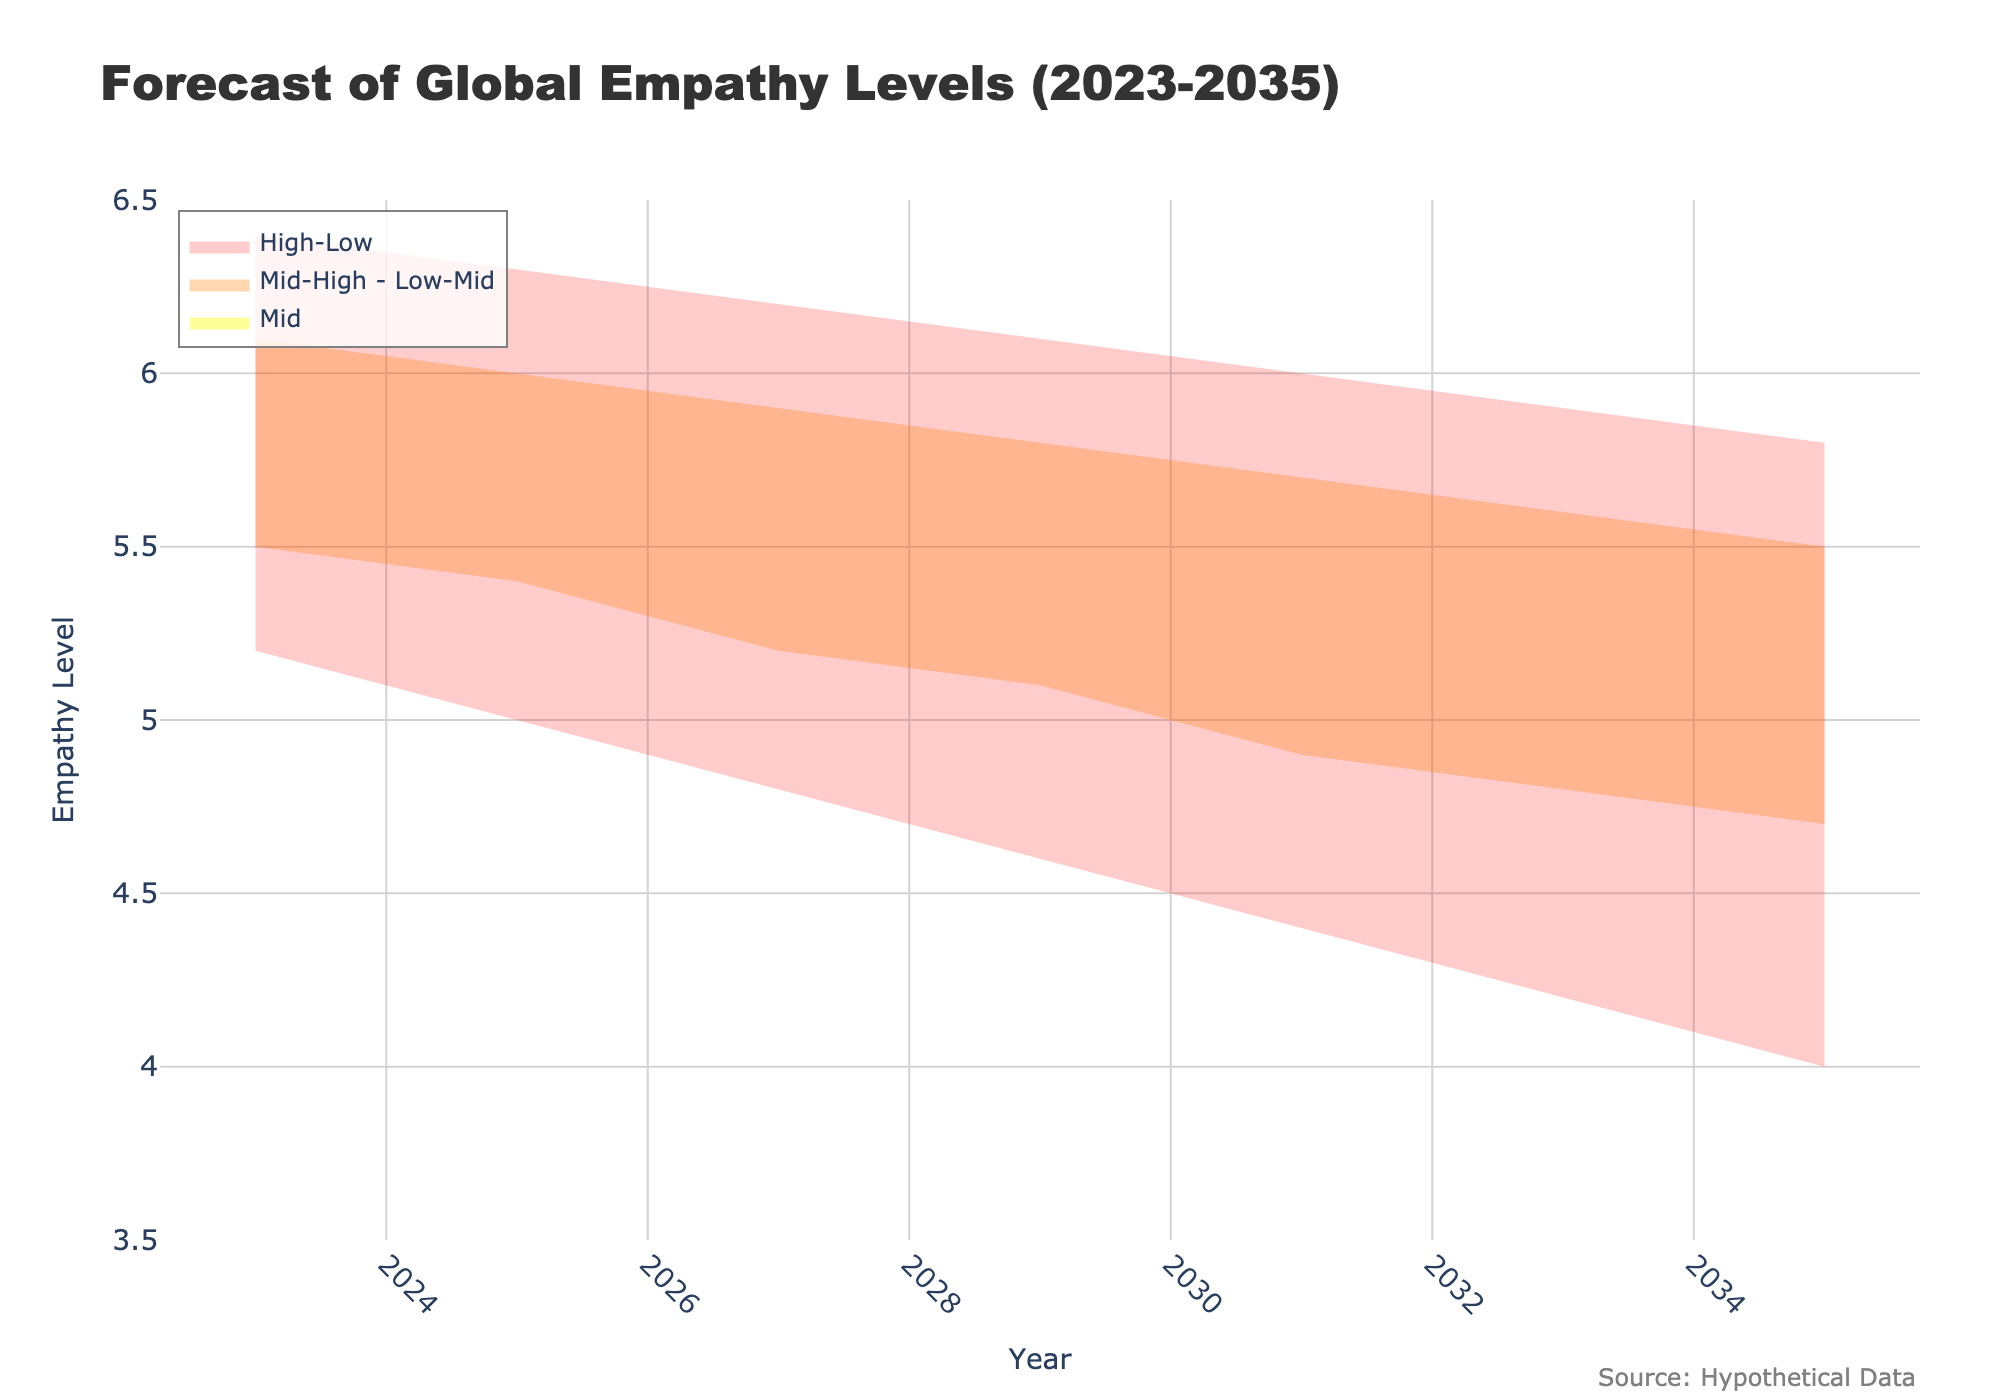what is the title of the plot? The title of the plot is located at the top of the figure and is typically larger in font size for easy identification.
Answer: "Forecast of Global Empathy Levels (2023-2035)" What is the range of the y-axis? To ascertain the range of the y-axis, one must look at the lowest and highest labeled values on the vertical axis.
Answer: 3.5 to 6.5 How does the Mid empathy level change from 2023 to 2035? To find the change, subtract the Mid empathy level in 2035 from the Mid empathy level in 2023: 5.8 - 5.2.
Answer: It decreases by 0.6 In which year is the predicted Low empathy level lowest? By comparing the Low values across all the years, one can identify which year has the smallest value.
Answer: 2035 What are the high and low bands for empathy levels in 2029? By observing the boundaries of the bands in the year 2029, one can determine the High and Low values.
Answer: High: 6.1, Low: 4.6 Which empathy level is expected to have the least variation over the forecasted years? By examining the bands' widths from 2023 to 2035, identifying the one with the least change gives the desired result.
Answer: Mid Compare the Mid-High and Low-Mid empathy bands in 2027. Which is greater? Look at the values for Mid-High and Low-Mid in 2027 to compare them directly.
Answer: Mid-High (5.9) is greater than Low-Mid (5.2) How does the breadth of the empathy level band (High-Low) change over the years? Analyze how the difference between the High and Low values changes from 2023 to 2035. For instance: Year 2023: 6.4-5.2=1.2, Year 2035: 5.8-4.0=1.8. The breadth increases with years.
Answer: It increases In which year do the Mid and Low-Mid empathy levels intersect? Locate the year where the Mid and Low-Mid bands have the same value or get closest.
Answer: They do not intersect; Mid is always higher What is the general trend of empathy levels from 2023 to 2035? By observing the direction of the bands (upward or downward sloping) over the years, you can determine the general trend.
Answer: Decreasing 